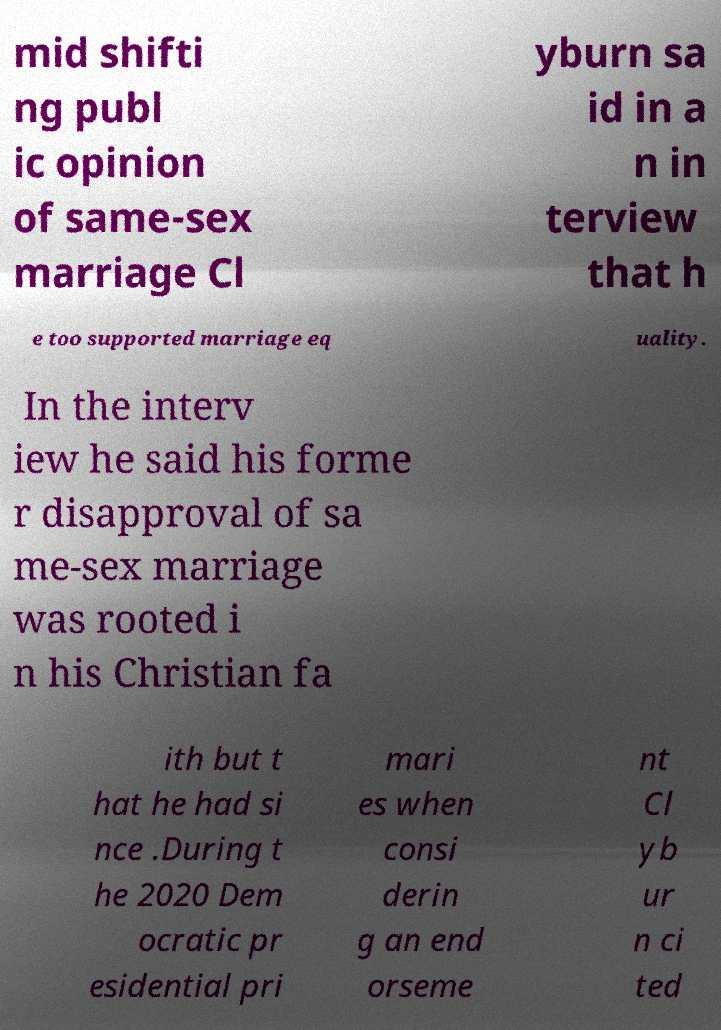Please read and relay the text visible in this image. What does it say? mid shifti ng publ ic opinion of same-sex marriage Cl yburn sa id in a n in terview that h e too supported marriage eq uality. In the interv iew he said his forme r disapproval of sa me-sex marriage was rooted i n his Christian fa ith but t hat he had si nce .During t he 2020 Dem ocratic pr esidential pri mari es when consi derin g an end orseme nt Cl yb ur n ci ted 